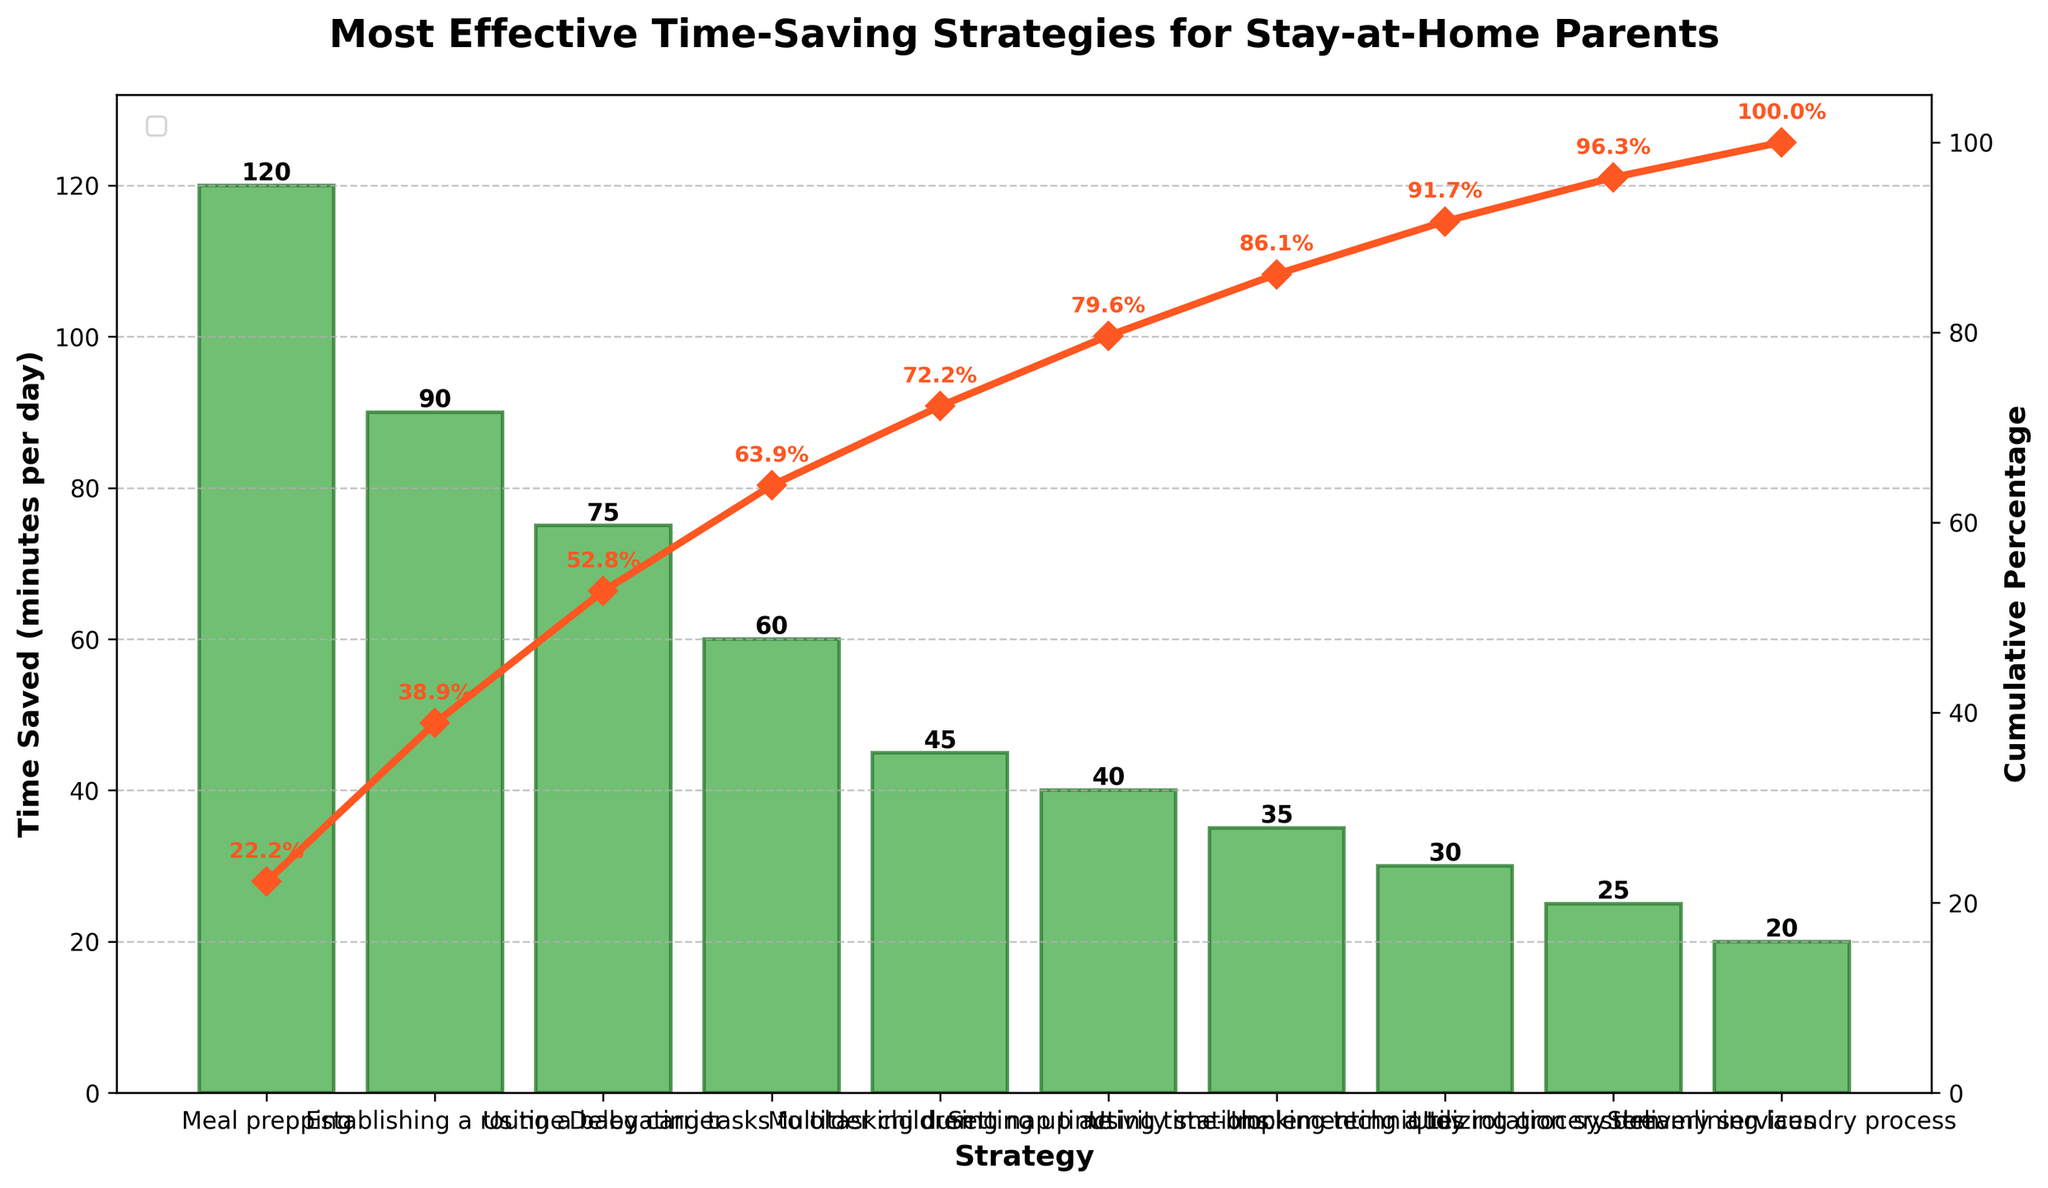What is the title of the chart? The title of the chart is displayed prominently at the top of the figure. It reads "Most Effective Time-Saving Strategies for Stay-at-Home Parents".
Answer: Most Effective Time-Saving Strategies for Stay-at-Home Parents What is the cumulative percentage after using baby carrier? Start from the top bar, which is meal prepping, and move down to the bar for using a baby carrier. The cumulative percentage is displayed next to each bar or marker on the cumulative line. For using a baby carrier, it shows 70.8%.
Answer: 70.8% Which strategy saves the most time per day? The strategy that saves the most time per day is the tallest bar in the Pareto chart. It is meal prepping.
Answer: Meal prepping How many strategies save more than 50 minutes per day? Check each bar's height and count those that exceed 50 minutes per day. Meal prepping, establishing a routine, using a baby carrier, and delegating tasks to older children all exceed 50 minutes.
Answer: 4 What is the total time saved by meal prepping and establishing a routine? Add the time saved for meal prepping (120 minutes) and establishing a routine (90 minutes). 120 + 90 = 210
Answer: 210 What percentage of the total time saved is achieved by the top three strategies combined? Sum the time saved for the top three strategies: meal prepping (120 minutes), establishing a routine (90 minutes), and using a baby carrier (75 minutes). The total time saved is 120 + 90 + 75 = 285 minutes. Divide by the total time saved by all strategies (540 minutes) and multiply by 100. (285 / 540) * 100 = 52.8%
Answer: 52.8% Is delegating tasks to older children more effective than multitasking during nap time? Compare the time saved by delegating tasks to older children (60 minutes) with multitasking during nap time (45 minutes). 60 minutes is more than 45 minutes.
Answer: Yes How does the cumulative percentage change from implementing a toy rotation system to utilizing grocery delivery services? Find the cumulative percentages for implementing a toy rotation system and utilizing grocery delivery services on the line plot. It is 93.1% for the toy rotation system and 97.8% for grocery delivery services. The change is 97.8% - 93.1% = 4.7%.
Answer: 4.7% increase Which two strategies combined save a total of 65 minutes per day? Identify combinations of two strategies whose total time saved equals 65 minutes. Implementing a toy rotation system (30 minutes) and using time-blocking techniques (35 minutes) combined save 30 + 35 = 65 minutes.
Answer: Implementing a toy rotation system and using time-blocking techniques What is the shortest bar on the chart, and how much time does it save? The shortest bar represents the strategy that saves the least amount of time per day. It is streamlining the laundry process, which saves 20 minutes per day.
Answer: Streamlining laundry process, 20 minutes 